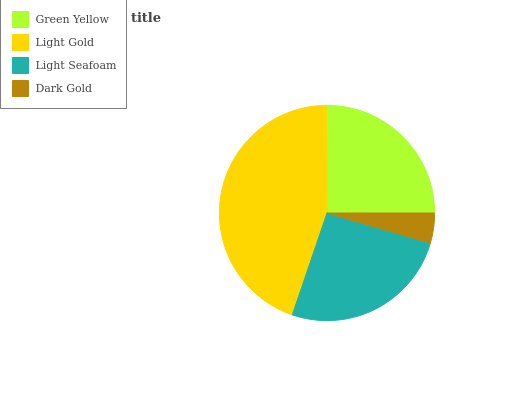Is Dark Gold the minimum?
Answer yes or no. Yes. Is Light Gold the maximum?
Answer yes or no. Yes. Is Light Seafoam the minimum?
Answer yes or no. No. Is Light Seafoam the maximum?
Answer yes or no. No. Is Light Gold greater than Light Seafoam?
Answer yes or no. Yes. Is Light Seafoam less than Light Gold?
Answer yes or no. Yes. Is Light Seafoam greater than Light Gold?
Answer yes or no. No. Is Light Gold less than Light Seafoam?
Answer yes or no. No. Is Light Seafoam the high median?
Answer yes or no. Yes. Is Green Yellow the low median?
Answer yes or no. Yes. Is Green Yellow the high median?
Answer yes or no. No. Is Light Gold the low median?
Answer yes or no. No. 